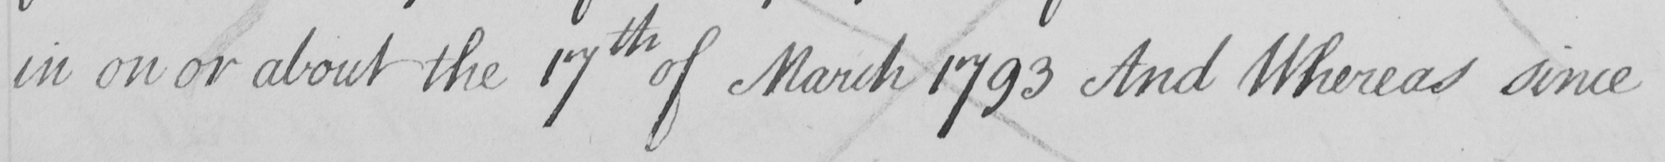Can you read and transcribe this handwriting? in on or about the 17th of March 1793 And Whereas since 